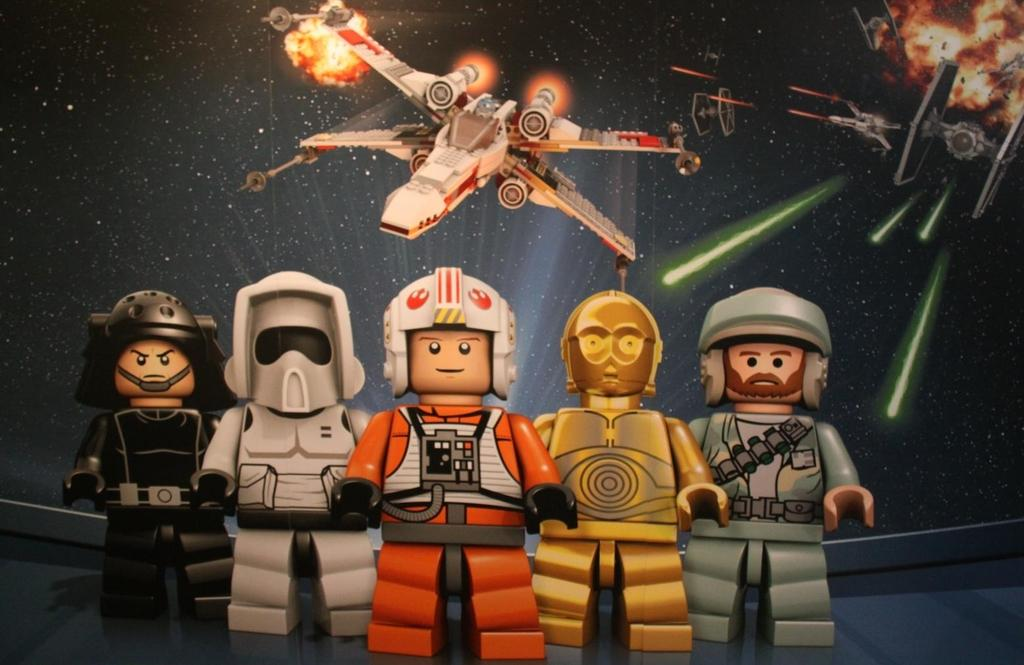What characters are located in the middle of the image? There are five superheroes in the middle of the image. What type of vehicles can be seen at the top of the image? There are air fighters at the top of the image. What is happening with the jet plane in the right side top corner of the image? There is a jet plane with fire in the right side top corner of the image. What type of list can be seen on the canvas in the image? There is no list or canvas present in the image. What color are the superheroes' lips in the image? The provided facts do not mention the color of the superheroes' lips, so it cannot be determined from the image. 